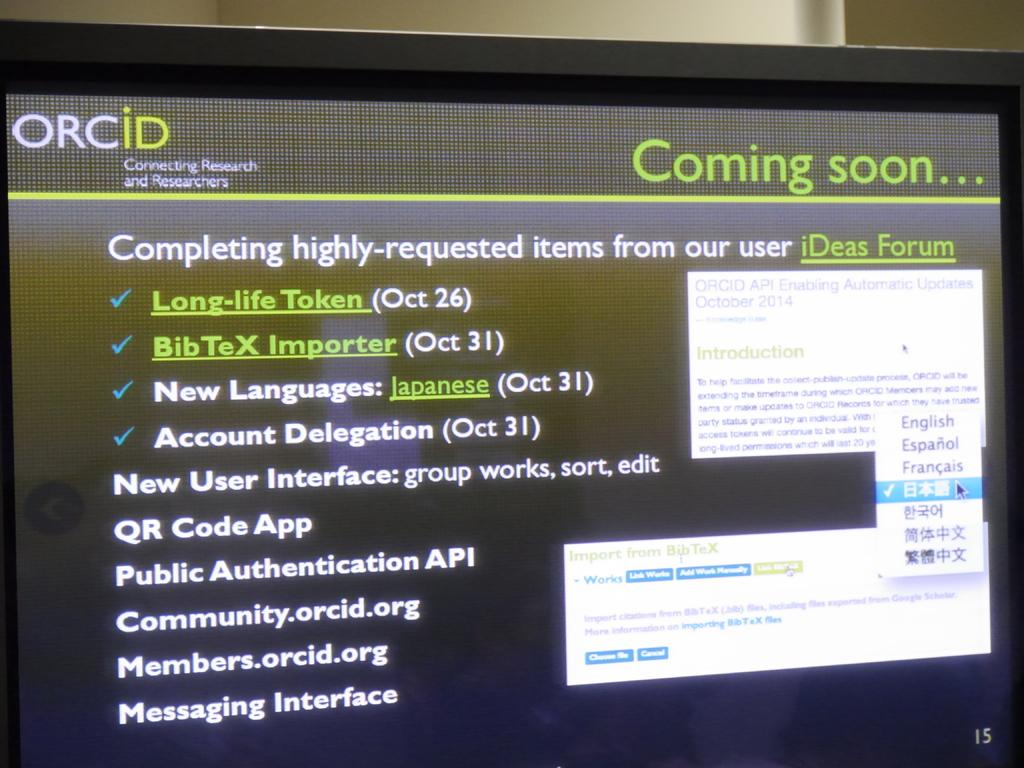Provide a one-sentence caption for the provided image. A coming soon screen advertising a new user interface. 